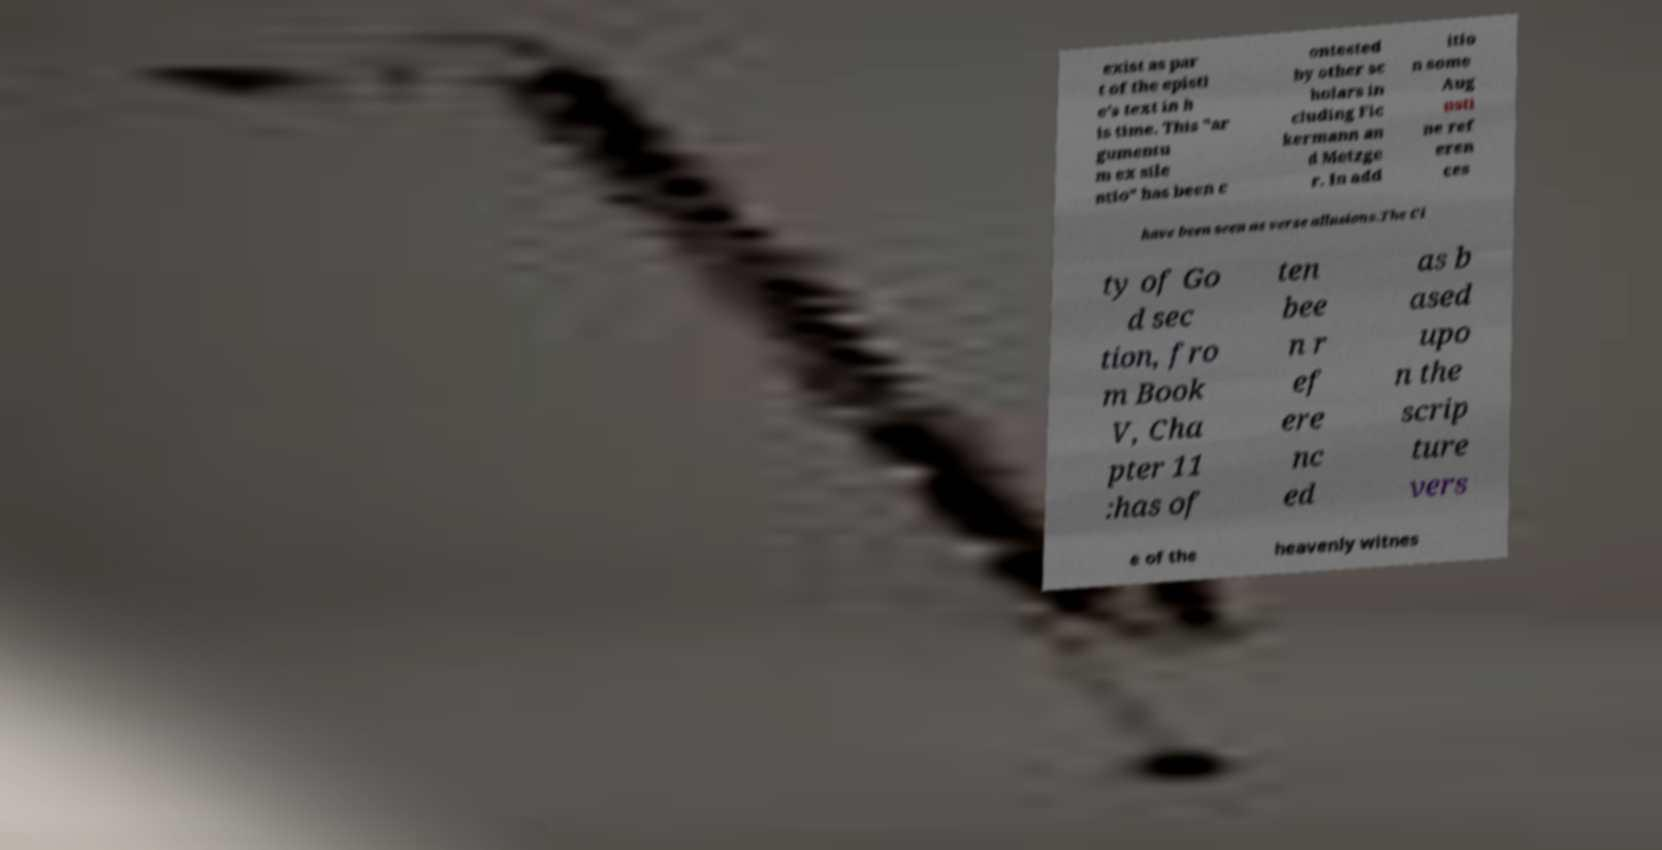What messages or text are displayed in this image? I need them in a readable, typed format. exist as par t of the epistl e's text in h is time. This "ar gumentu m ex sile ntio" has been c ontested by other sc holars in cluding Fic kermann an d Metzge r. In add itio n some Aug usti ne ref eren ces have been seen as verse allusions.The Ci ty of Go d sec tion, fro m Book V, Cha pter 11 :has of ten bee n r ef ere nc ed as b ased upo n the scrip ture vers e of the heavenly witnes 